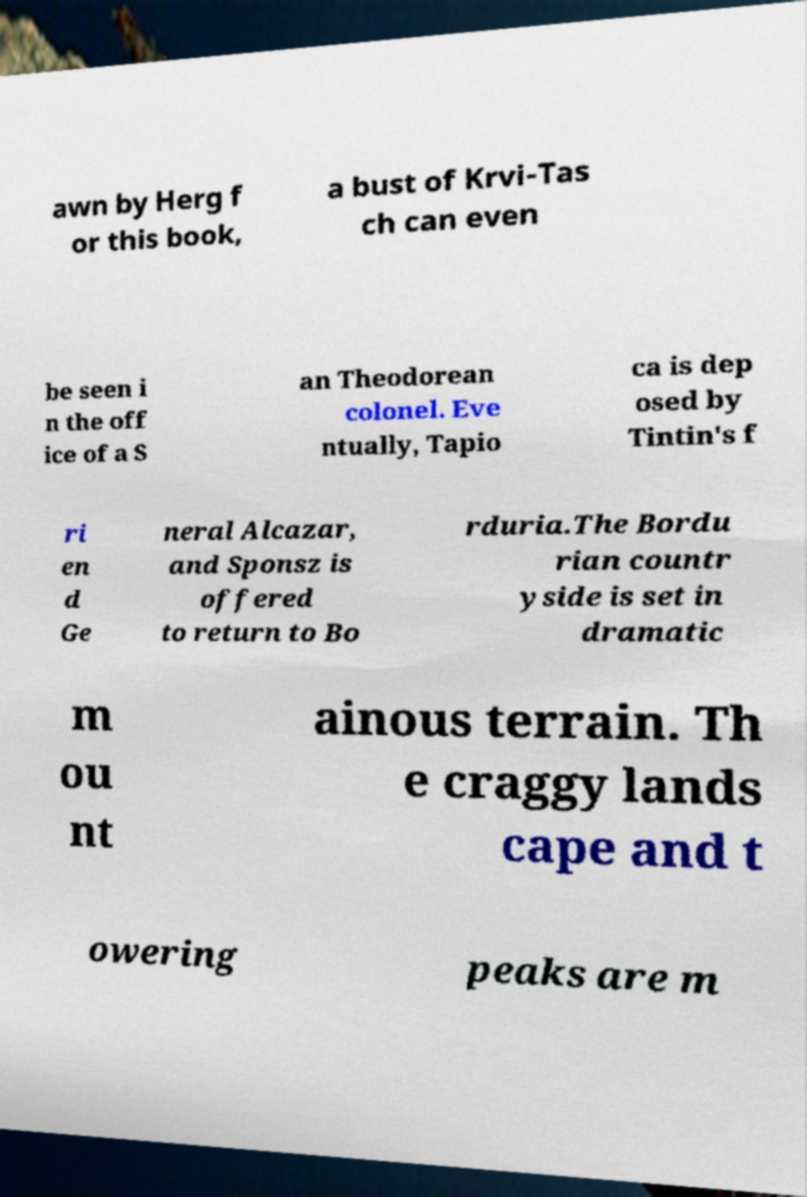What messages or text are displayed in this image? I need them in a readable, typed format. awn by Herg f or this book, a bust of Krvi-Tas ch can even be seen i n the off ice of a S an Theodorean colonel. Eve ntually, Tapio ca is dep osed by Tintin's f ri en d Ge neral Alcazar, and Sponsz is offered to return to Bo rduria.The Bordu rian countr yside is set in dramatic m ou nt ainous terrain. Th e craggy lands cape and t owering peaks are m 